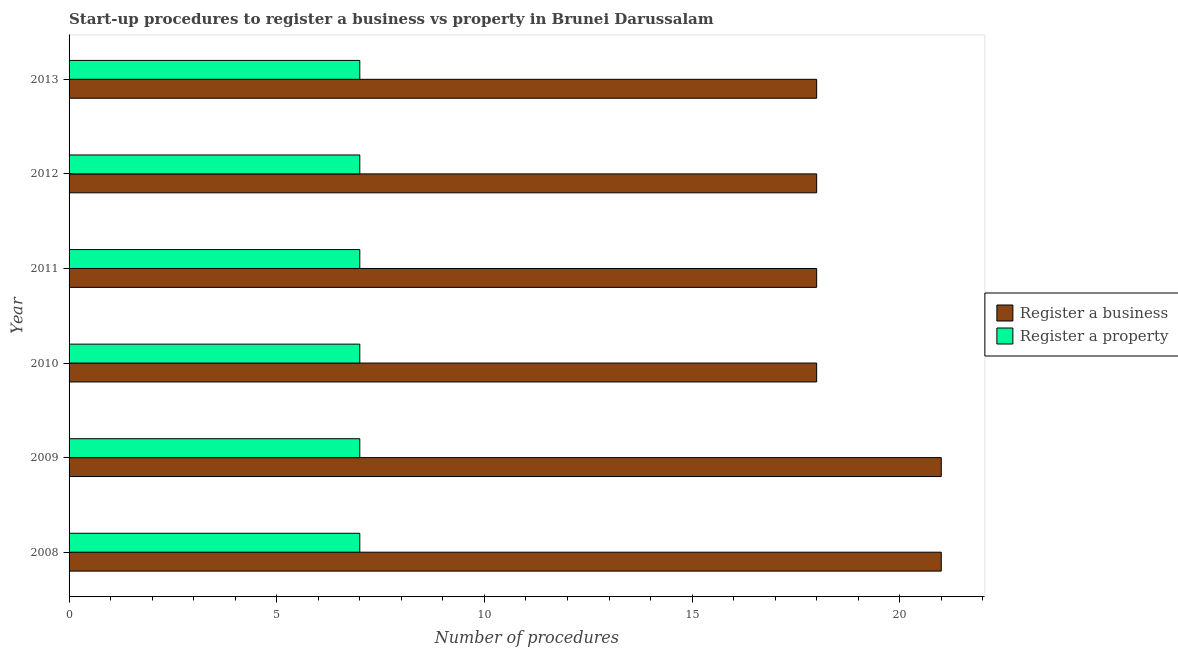How many different coloured bars are there?
Provide a short and direct response. 2. Are the number of bars on each tick of the Y-axis equal?
Offer a terse response. Yes. How many bars are there on the 1st tick from the bottom?
Your answer should be very brief. 2. What is the label of the 4th group of bars from the top?
Offer a very short reply. 2010. In how many cases, is the number of bars for a given year not equal to the number of legend labels?
Provide a short and direct response. 0. What is the number of procedures to register a business in 2013?
Provide a succinct answer. 18. Across all years, what is the maximum number of procedures to register a business?
Your answer should be very brief. 21. Across all years, what is the minimum number of procedures to register a business?
Offer a very short reply. 18. What is the total number of procedures to register a property in the graph?
Your answer should be compact. 42. What is the difference between the number of procedures to register a property in 2010 and that in 2013?
Offer a very short reply. 0. What is the difference between the number of procedures to register a property in 2011 and the number of procedures to register a business in 2010?
Your answer should be very brief. -11. What is the average number of procedures to register a property per year?
Offer a very short reply. 7. In the year 2012, what is the difference between the number of procedures to register a property and number of procedures to register a business?
Provide a succinct answer. -11. What is the difference between the highest and the lowest number of procedures to register a property?
Provide a short and direct response. 0. Is the sum of the number of procedures to register a property in 2008 and 2012 greater than the maximum number of procedures to register a business across all years?
Your response must be concise. No. What does the 2nd bar from the top in 2013 represents?
Provide a short and direct response. Register a business. What does the 2nd bar from the bottom in 2013 represents?
Your response must be concise. Register a property. Are all the bars in the graph horizontal?
Your answer should be compact. Yes. What is the difference between two consecutive major ticks on the X-axis?
Offer a terse response. 5. Are the values on the major ticks of X-axis written in scientific E-notation?
Make the answer very short. No. How are the legend labels stacked?
Keep it short and to the point. Vertical. What is the title of the graph?
Your response must be concise. Start-up procedures to register a business vs property in Brunei Darussalam. Does "Grants" appear as one of the legend labels in the graph?
Ensure brevity in your answer.  No. What is the label or title of the X-axis?
Offer a very short reply. Number of procedures. What is the label or title of the Y-axis?
Keep it short and to the point. Year. What is the Number of procedures in Register a property in 2008?
Give a very brief answer. 7. What is the Number of procedures of Register a business in 2009?
Make the answer very short. 21. What is the Number of procedures of Register a property in 2010?
Keep it short and to the point. 7. What is the Number of procedures of Register a business in 2011?
Make the answer very short. 18. What is the Number of procedures in Register a property in 2011?
Your answer should be compact. 7. What is the Number of procedures of Register a business in 2012?
Offer a very short reply. 18. What is the Number of procedures in Register a property in 2012?
Make the answer very short. 7. What is the Number of procedures in Register a property in 2013?
Your answer should be very brief. 7. Across all years, what is the minimum Number of procedures in Register a business?
Make the answer very short. 18. What is the total Number of procedures in Register a business in the graph?
Your response must be concise. 114. What is the total Number of procedures in Register a property in the graph?
Offer a terse response. 42. What is the difference between the Number of procedures of Register a business in 2008 and that in 2009?
Ensure brevity in your answer.  0. What is the difference between the Number of procedures of Register a business in 2008 and that in 2011?
Provide a succinct answer. 3. What is the difference between the Number of procedures of Register a property in 2008 and that in 2011?
Make the answer very short. 0. What is the difference between the Number of procedures in Register a business in 2008 and that in 2012?
Your answer should be compact. 3. What is the difference between the Number of procedures of Register a property in 2008 and that in 2013?
Your answer should be very brief. 0. What is the difference between the Number of procedures in Register a property in 2009 and that in 2012?
Give a very brief answer. 0. What is the difference between the Number of procedures in Register a business in 2009 and that in 2013?
Your response must be concise. 3. What is the difference between the Number of procedures of Register a business in 2010 and that in 2012?
Give a very brief answer. 0. What is the difference between the Number of procedures in Register a property in 2010 and that in 2012?
Offer a terse response. 0. What is the difference between the Number of procedures in Register a business in 2011 and that in 2012?
Make the answer very short. 0. What is the difference between the Number of procedures in Register a property in 2011 and that in 2012?
Provide a short and direct response. 0. What is the difference between the Number of procedures in Register a business in 2011 and that in 2013?
Provide a short and direct response. 0. What is the difference between the Number of procedures in Register a property in 2011 and that in 2013?
Ensure brevity in your answer.  0. What is the difference between the Number of procedures of Register a property in 2012 and that in 2013?
Your answer should be compact. 0. What is the difference between the Number of procedures in Register a business in 2008 and the Number of procedures in Register a property in 2010?
Make the answer very short. 14. What is the difference between the Number of procedures of Register a business in 2008 and the Number of procedures of Register a property in 2011?
Keep it short and to the point. 14. What is the difference between the Number of procedures in Register a business in 2008 and the Number of procedures in Register a property in 2012?
Provide a short and direct response. 14. What is the difference between the Number of procedures of Register a business in 2008 and the Number of procedures of Register a property in 2013?
Your answer should be compact. 14. What is the difference between the Number of procedures of Register a business in 2009 and the Number of procedures of Register a property in 2010?
Make the answer very short. 14. What is the difference between the Number of procedures in Register a business in 2009 and the Number of procedures in Register a property in 2011?
Offer a very short reply. 14. What is the difference between the Number of procedures in Register a business in 2009 and the Number of procedures in Register a property in 2012?
Provide a short and direct response. 14. What is the difference between the Number of procedures in Register a business in 2010 and the Number of procedures in Register a property in 2011?
Offer a terse response. 11. What is the difference between the Number of procedures of Register a business in 2010 and the Number of procedures of Register a property in 2013?
Offer a very short reply. 11. What is the difference between the Number of procedures in Register a business in 2011 and the Number of procedures in Register a property in 2012?
Keep it short and to the point. 11. In the year 2008, what is the difference between the Number of procedures in Register a business and Number of procedures in Register a property?
Keep it short and to the point. 14. In the year 2009, what is the difference between the Number of procedures in Register a business and Number of procedures in Register a property?
Provide a short and direct response. 14. In the year 2010, what is the difference between the Number of procedures in Register a business and Number of procedures in Register a property?
Provide a succinct answer. 11. In the year 2011, what is the difference between the Number of procedures in Register a business and Number of procedures in Register a property?
Your answer should be very brief. 11. In the year 2012, what is the difference between the Number of procedures in Register a business and Number of procedures in Register a property?
Keep it short and to the point. 11. What is the ratio of the Number of procedures of Register a business in 2008 to that in 2010?
Provide a succinct answer. 1.17. What is the ratio of the Number of procedures of Register a property in 2008 to that in 2010?
Your answer should be compact. 1. What is the ratio of the Number of procedures in Register a business in 2008 to that in 2012?
Offer a terse response. 1.17. What is the ratio of the Number of procedures of Register a property in 2008 to that in 2012?
Your answer should be very brief. 1. What is the ratio of the Number of procedures in Register a property in 2008 to that in 2013?
Your response must be concise. 1. What is the ratio of the Number of procedures of Register a business in 2009 to that in 2011?
Your answer should be very brief. 1.17. What is the ratio of the Number of procedures of Register a business in 2009 to that in 2012?
Offer a very short reply. 1.17. What is the ratio of the Number of procedures in Register a business in 2009 to that in 2013?
Your response must be concise. 1.17. What is the ratio of the Number of procedures in Register a business in 2010 to that in 2011?
Your answer should be very brief. 1. What is the ratio of the Number of procedures of Register a business in 2010 to that in 2012?
Your answer should be very brief. 1. What is the ratio of the Number of procedures in Register a property in 2010 to that in 2012?
Provide a succinct answer. 1. What is the ratio of the Number of procedures in Register a business in 2010 to that in 2013?
Offer a terse response. 1. What is the ratio of the Number of procedures of Register a property in 2010 to that in 2013?
Provide a short and direct response. 1. What is the ratio of the Number of procedures of Register a property in 2011 to that in 2012?
Provide a succinct answer. 1. What is the ratio of the Number of procedures of Register a business in 2011 to that in 2013?
Provide a short and direct response. 1. What is the ratio of the Number of procedures of Register a business in 2012 to that in 2013?
Offer a terse response. 1. What is the ratio of the Number of procedures of Register a property in 2012 to that in 2013?
Make the answer very short. 1. 